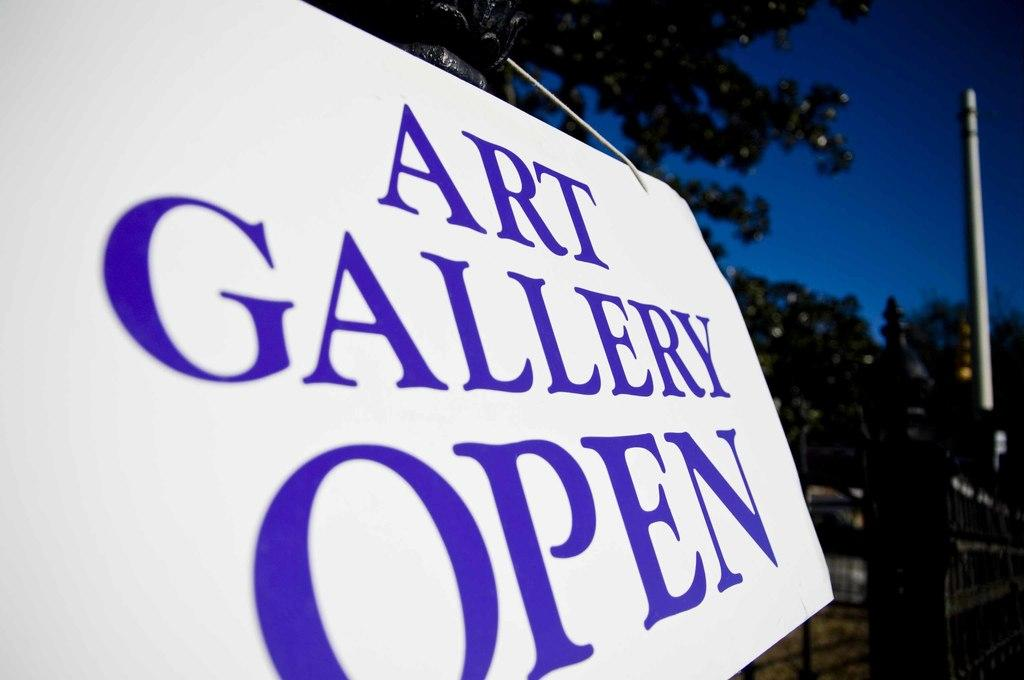What is the main object in the image? There is a white color board in the image. What is written or displayed on the board? There is text on the board. What type of natural scenery is visible in the image? There are trees visible in the image. How many apples are hanging from the trees in the image? There are no apples visible in the image; only trees are present. What type of base is supporting the color board in the image? The provided facts do not mention a base supporting the color board, so it cannot be determined from the image. 